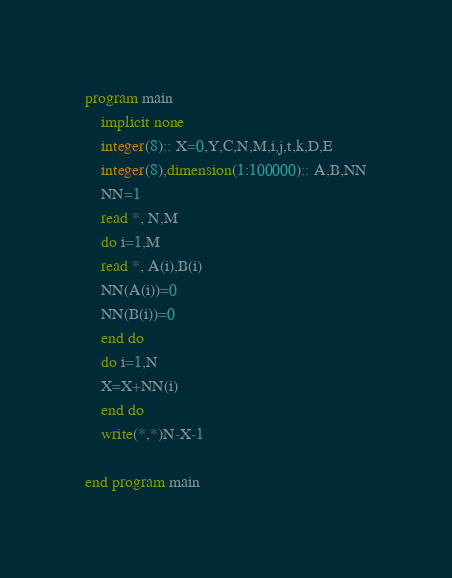Convert code to text. <code><loc_0><loc_0><loc_500><loc_500><_FORTRAN_>program main
	implicit none
	integer(8):: X=0,Y,C,N,M,i,j,t,k,D,E
    integer(8),dimension(1:100000):: A,B,NN
    NN=1
	read *, N,M
    do i=1,M
    read *, A(i),B(i)
    NN(A(i))=0
    NN(B(i))=0
    end do
    do i=1,N
    X=X+NN(i)
    end do
    write(*,*)N-X-1
   
end program main</code> 